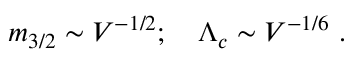Convert formula to latex. <formula><loc_0><loc_0><loc_500><loc_500>m _ { 3 / 2 } \sim V ^ { - 1 / 2 } ; \quad \Lambda _ { c } \sim V ^ { - 1 / 6 } \ .</formula> 